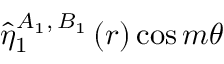Convert formula to latex. <formula><loc_0><loc_0><loc_500><loc_500>\hat { \eta } _ { 1 } ^ { A _ { 1 } , \, B _ { 1 } } \left ( r \right ) \cos { m \theta }</formula> 